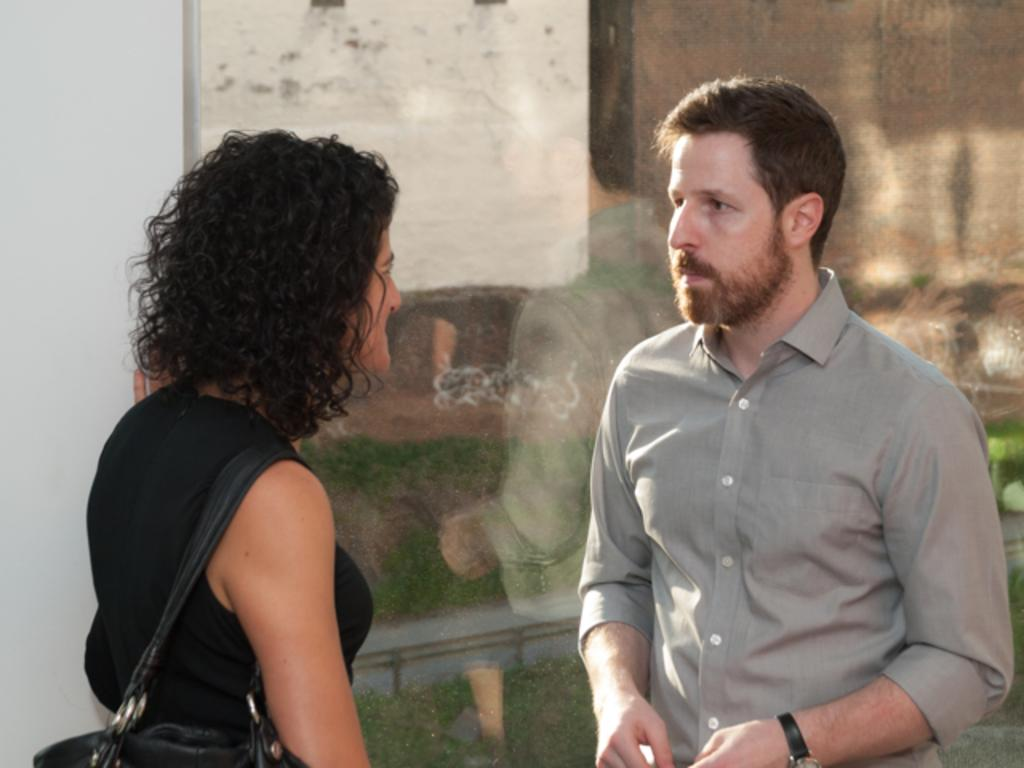Who or what can be seen in the image? There are people in the image. What can be seen in the background of the image? There is glass visible in the background of the image. What is happening to the glass in the image? There are reflections on the glass. What type of powder can be seen falling from the top of the image? There is no powder visible in the image, and nothing is falling from the top of the image. 